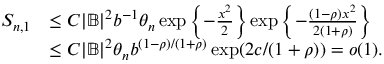<formula> <loc_0><loc_0><loc_500><loc_500>\begin{array} { r l } { S _ { n , 1 } } & { \leq C | \mathbb { B } | ^ { 2 } b ^ { - 1 } \theta _ { n } \exp \left \{ - \frac { x ^ { 2 } } { 2 } \right \} \exp \left \{ - \frac { ( 1 - \rho ) x ^ { 2 } } { 2 ( 1 + \rho ) } \right \} } \\ & { \leq C | \mathbb { B } | ^ { 2 } \theta _ { n } b ^ { ( 1 - \rho ) / ( 1 + \rho ) } \exp ( 2 c / ( 1 + \rho ) ) = o ( 1 ) . } \end{array}</formula> 